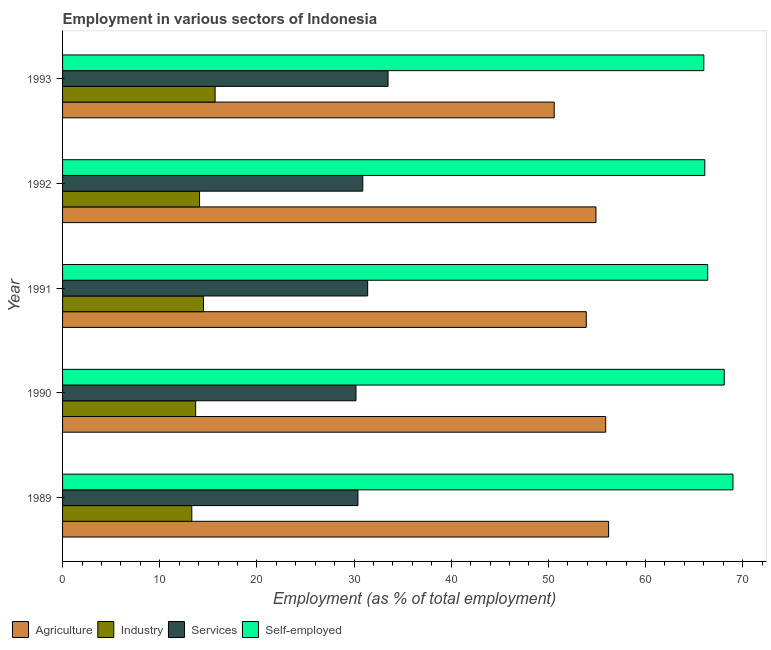How many different coloured bars are there?
Ensure brevity in your answer.  4. How many groups of bars are there?
Your response must be concise. 5. Are the number of bars per tick equal to the number of legend labels?
Your answer should be very brief. Yes. Are the number of bars on each tick of the Y-axis equal?
Keep it short and to the point. Yes. How many bars are there on the 3rd tick from the top?
Offer a terse response. 4. What is the label of the 1st group of bars from the top?
Make the answer very short. 1993. What is the percentage of self employed workers in 1991?
Keep it short and to the point. 66.4. Across all years, what is the maximum percentage of workers in services?
Offer a terse response. 33.5. Across all years, what is the minimum percentage of self employed workers?
Your answer should be very brief. 66. In which year was the percentage of workers in services maximum?
Provide a short and direct response. 1993. What is the total percentage of workers in industry in the graph?
Offer a terse response. 71.3. What is the average percentage of workers in services per year?
Provide a short and direct response. 31.28. In the year 1993, what is the difference between the percentage of workers in services and percentage of self employed workers?
Offer a very short reply. -32.5. What is the ratio of the percentage of workers in agriculture in 1989 to that in 1991?
Your answer should be very brief. 1.04. What does the 2nd bar from the top in 1991 represents?
Your response must be concise. Services. What does the 4th bar from the bottom in 1992 represents?
Keep it short and to the point. Self-employed. Is it the case that in every year, the sum of the percentage of workers in agriculture and percentage of workers in industry is greater than the percentage of workers in services?
Your answer should be compact. Yes. How many bars are there?
Provide a succinct answer. 20. Are all the bars in the graph horizontal?
Provide a succinct answer. Yes. How many years are there in the graph?
Offer a terse response. 5. Does the graph contain grids?
Offer a terse response. No. How many legend labels are there?
Give a very brief answer. 4. What is the title of the graph?
Give a very brief answer. Employment in various sectors of Indonesia. Does "Secondary schools" appear as one of the legend labels in the graph?
Ensure brevity in your answer.  No. What is the label or title of the X-axis?
Your answer should be very brief. Employment (as % of total employment). What is the Employment (as % of total employment) of Agriculture in 1989?
Provide a succinct answer. 56.2. What is the Employment (as % of total employment) of Industry in 1989?
Ensure brevity in your answer.  13.3. What is the Employment (as % of total employment) of Services in 1989?
Your answer should be very brief. 30.4. What is the Employment (as % of total employment) of Self-employed in 1989?
Provide a succinct answer. 69. What is the Employment (as % of total employment) in Agriculture in 1990?
Provide a short and direct response. 55.9. What is the Employment (as % of total employment) in Industry in 1990?
Make the answer very short. 13.7. What is the Employment (as % of total employment) of Services in 1990?
Your answer should be very brief. 30.2. What is the Employment (as % of total employment) of Self-employed in 1990?
Your answer should be compact. 68.1. What is the Employment (as % of total employment) of Agriculture in 1991?
Provide a short and direct response. 53.9. What is the Employment (as % of total employment) of Services in 1991?
Your answer should be compact. 31.4. What is the Employment (as % of total employment) in Self-employed in 1991?
Your response must be concise. 66.4. What is the Employment (as % of total employment) of Agriculture in 1992?
Offer a very short reply. 54.9. What is the Employment (as % of total employment) in Industry in 1992?
Your answer should be very brief. 14.1. What is the Employment (as % of total employment) in Services in 1992?
Your answer should be compact. 30.9. What is the Employment (as % of total employment) in Self-employed in 1992?
Provide a short and direct response. 66.1. What is the Employment (as % of total employment) in Agriculture in 1993?
Your response must be concise. 50.6. What is the Employment (as % of total employment) in Industry in 1993?
Make the answer very short. 15.7. What is the Employment (as % of total employment) of Services in 1993?
Give a very brief answer. 33.5. Across all years, what is the maximum Employment (as % of total employment) of Agriculture?
Make the answer very short. 56.2. Across all years, what is the maximum Employment (as % of total employment) of Industry?
Your answer should be compact. 15.7. Across all years, what is the maximum Employment (as % of total employment) in Services?
Keep it short and to the point. 33.5. Across all years, what is the minimum Employment (as % of total employment) of Agriculture?
Your answer should be compact. 50.6. Across all years, what is the minimum Employment (as % of total employment) in Industry?
Ensure brevity in your answer.  13.3. Across all years, what is the minimum Employment (as % of total employment) of Services?
Offer a very short reply. 30.2. Across all years, what is the minimum Employment (as % of total employment) of Self-employed?
Provide a short and direct response. 66. What is the total Employment (as % of total employment) of Agriculture in the graph?
Provide a succinct answer. 271.5. What is the total Employment (as % of total employment) in Industry in the graph?
Give a very brief answer. 71.3. What is the total Employment (as % of total employment) in Services in the graph?
Offer a terse response. 156.4. What is the total Employment (as % of total employment) in Self-employed in the graph?
Keep it short and to the point. 335.6. What is the difference between the Employment (as % of total employment) in Agriculture in 1989 and that in 1990?
Provide a short and direct response. 0.3. What is the difference between the Employment (as % of total employment) of Agriculture in 1989 and that in 1992?
Make the answer very short. 1.3. What is the difference between the Employment (as % of total employment) in Industry in 1989 and that in 1992?
Your answer should be compact. -0.8. What is the difference between the Employment (as % of total employment) of Industry in 1989 and that in 1993?
Give a very brief answer. -2.4. What is the difference between the Employment (as % of total employment) in Agriculture in 1990 and that in 1991?
Your response must be concise. 2. What is the difference between the Employment (as % of total employment) in Industry in 1990 and that in 1991?
Give a very brief answer. -0.8. What is the difference between the Employment (as % of total employment) in Agriculture in 1990 and that in 1992?
Your answer should be compact. 1. What is the difference between the Employment (as % of total employment) in Industry in 1990 and that in 1992?
Ensure brevity in your answer.  -0.4. What is the difference between the Employment (as % of total employment) in Agriculture in 1990 and that in 1993?
Make the answer very short. 5.3. What is the difference between the Employment (as % of total employment) of Services in 1991 and that in 1992?
Make the answer very short. 0.5. What is the difference between the Employment (as % of total employment) of Self-employed in 1991 and that in 1993?
Ensure brevity in your answer.  0.4. What is the difference between the Employment (as % of total employment) of Agriculture in 1992 and that in 1993?
Offer a terse response. 4.3. What is the difference between the Employment (as % of total employment) in Industry in 1992 and that in 1993?
Your answer should be very brief. -1.6. What is the difference between the Employment (as % of total employment) of Self-employed in 1992 and that in 1993?
Keep it short and to the point. 0.1. What is the difference between the Employment (as % of total employment) in Agriculture in 1989 and the Employment (as % of total employment) in Industry in 1990?
Keep it short and to the point. 42.5. What is the difference between the Employment (as % of total employment) in Agriculture in 1989 and the Employment (as % of total employment) in Services in 1990?
Offer a very short reply. 26. What is the difference between the Employment (as % of total employment) of Agriculture in 1989 and the Employment (as % of total employment) of Self-employed in 1990?
Make the answer very short. -11.9. What is the difference between the Employment (as % of total employment) of Industry in 1989 and the Employment (as % of total employment) of Services in 1990?
Offer a very short reply. -16.9. What is the difference between the Employment (as % of total employment) of Industry in 1989 and the Employment (as % of total employment) of Self-employed in 1990?
Your response must be concise. -54.8. What is the difference between the Employment (as % of total employment) in Services in 1989 and the Employment (as % of total employment) in Self-employed in 1990?
Offer a very short reply. -37.7. What is the difference between the Employment (as % of total employment) of Agriculture in 1989 and the Employment (as % of total employment) of Industry in 1991?
Provide a short and direct response. 41.7. What is the difference between the Employment (as % of total employment) of Agriculture in 1989 and the Employment (as % of total employment) of Services in 1991?
Make the answer very short. 24.8. What is the difference between the Employment (as % of total employment) in Industry in 1989 and the Employment (as % of total employment) in Services in 1991?
Your answer should be compact. -18.1. What is the difference between the Employment (as % of total employment) of Industry in 1989 and the Employment (as % of total employment) of Self-employed in 1991?
Your response must be concise. -53.1. What is the difference between the Employment (as % of total employment) in Services in 1989 and the Employment (as % of total employment) in Self-employed in 1991?
Make the answer very short. -36. What is the difference between the Employment (as % of total employment) of Agriculture in 1989 and the Employment (as % of total employment) of Industry in 1992?
Ensure brevity in your answer.  42.1. What is the difference between the Employment (as % of total employment) of Agriculture in 1989 and the Employment (as % of total employment) of Services in 1992?
Provide a succinct answer. 25.3. What is the difference between the Employment (as % of total employment) of Agriculture in 1989 and the Employment (as % of total employment) of Self-employed in 1992?
Provide a short and direct response. -9.9. What is the difference between the Employment (as % of total employment) of Industry in 1989 and the Employment (as % of total employment) of Services in 1992?
Your answer should be compact. -17.6. What is the difference between the Employment (as % of total employment) of Industry in 1989 and the Employment (as % of total employment) of Self-employed in 1992?
Ensure brevity in your answer.  -52.8. What is the difference between the Employment (as % of total employment) in Services in 1989 and the Employment (as % of total employment) in Self-employed in 1992?
Ensure brevity in your answer.  -35.7. What is the difference between the Employment (as % of total employment) of Agriculture in 1989 and the Employment (as % of total employment) of Industry in 1993?
Keep it short and to the point. 40.5. What is the difference between the Employment (as % of total employment) in Agriculture in 1989 and the Employment (as % of total employment) in Services in 1993?
Make the answer very short. 22.7. What is the difference between the Employment (as % of total employment) of Industry in 1989 and the Employment (as % of total employment) of Services in 1993?
Keep it short and to the point. -20.2. What is the difference between the Employment (as % of total employment) in Industry in 1989 and the Employment (as % of total employment) in Self-employed in 1993?
Offer a terse response. -52.7. What is the difference between the Employment (as % of total employment) of Services in 1989 and the Employment (as % of total employment) of Self-employed in 1993?
Make the answer very short. -35.6. What is the difference between the Employment (as % of total employment) of Agriculture in 1990 and the Employment (as % of total employment) of Industry in 1991?
Provide a short and direct response. 41.4. What is the difference between the Employment (as % of total employment) of Agriculture in 1990 and the Employment (as % of total employment) of Services in 1991?
Your response must be concise. 24.5. What is the difference between the Employment (as % of total employment) in Industry in 1990 and the Employment (as % of total employment) in Services in 1991?
Provide a succinct answer. -17.7. What is the difference between the Employment (as % of total employment) of Industry in 1990 and the Employment (as % of total employment) of Self-employed in 1991?
Keep it short and to the point. -52.7. What is the difference between the Employment (as % of total employment) of Services in 1990 and the Employment (as % of total employment) of Self-employed in 1991?
Ensure brevity in your answer.  -36.2. What is the difference between the Employment (as % of total employment) in Agriculture in 1990 and the Employment (as % of total employment) in Industry in 1992?
Offer a very short reply. 41.8. What is the difference between the Employment (as % of total employment) of Agriculture in 1990 and the Employment (as % of total employment) of Self-employed in 1992?
Offer a terse response. -10.2. What is the difference between the Employment (as % of total employment) of Industry in 1990 and the Employment (as % of total employment) of Services in 1992?
Give a very brief answer. -17.2. What is the difference between the Employment (as % of total employment) of Industry in 1990 and the Employment (as % of total employment) of Self-employed in 1992?
Provide a succinct answer. -52.4. What is the difference between the Employment (as % of total employment) in Services in 1990 and the Employment (as % of total employment) in Self-employed in 1992?
Provide a succinct answer. -35.9. What is the difference between the Employment (as % of total employment) of Agriculture in 1990 and the Employment (as % of total employment) of Industry in 1993?
Make the answer very short. 40.2. What is the difference between the Employment (as % of total employment) of Agriculture in 1990 and the Employment (as % of total employment) of Services in 1993?
Give a very brief answer. 22.4. What is the difference between the Employment (as % of total employment) of Agriculture in 1990 and the Employment (as % of total employment) of Self-employed in 1993?
Offer a very short reply. -10.1. What is the difference between the Employment (as % of total employment) in Industry in 1990 and the Employment (as % of total employment) in Services in 1993?
Offer a very short reply. -19.8. What is the difference between the Employment (as % of total employment) in Industry in 1990 and the Employment (as % of total employment) in Self-employed in 1993?
Offer a terse response. -52.3. What is the difference between the Employment (as % of total employment) of Services in 1990 and the Employment (as % of total employment) of Self-employed in 1993?
Ensure brevity in your answer.  -35.8. What is the difference between the Employment (as % of total employment) of Agriculture in 1991 and the Employment (as % of total employment) of Industry in 1992?
Keep it short and to the point. 39.8. What is the difference between the Employment (as % of total employment) of Agriculture in 1991 and the Employment (as % of total employment) of Services in 1992?
Your response must be concise. 23. What is the difference between the Employment (as % of total employment) of Industry in 1991 and the Employment (as % of total employment) of Services in 1992?
Provide a short and direct response. -16.4. What is the difference between the Employment (as % of total employment) in Industry in 1991 and the Employment (as % of total employment) in Self-employed in 1992?
Ensure brevity in your answer.  -51.6. What is the difference between the Employment (as % of total employment) of Services in 1991 and the Employment (as % of total employment) of Self-employed in 1992?
Give a very brief answer. -34.7. What is the difference between the Employment (as % of total employment) in Agriculture in 1991 and the Employment (as % of total employment) in Industry in 1993?
Keep it short and to the point. 38.2. What is the difference between the Employment (as % of total employment) of Agriculture in 1991 and the Employment (as % of total employment) of Services in 1993?
Ensure brevity in your answer.  20.4. What is the difference between the Employment (as % of total employment) of Industry in 1991 and the Employment (as % of total employment) of Services in 1993?
Provide a succinct answer. -19. What is the difference between the Employment (as % of total employment) of Industry in 1991 and the Employment (as % of total employment) of Self-employed in 1993?
Your response must be concise. -51.5. What is the difference between the Employment (as % of total employment) of Services in 1991 and the Employment (as % of total employment) of Self-employed in 1993?
Offer a very short reply. -34.6. What is the difference between the Employment (as % of total employment) in Agriculture in 1992 and the Employment (as % of total employment) in Industry in 1993?
Give a very brief answer. 39.2. What is the difference between the Employment (as % of total employment) of Agriculture in 1992 and the Employment (as % of total employment) of Services in 1993?
Make the answer very short. 21.4. What is the difference between the Employment (as % of total employment) of Agriculture in 1992 and the Employment (as % of total employment) of Self-employed in 1993?
Your answer should be very brief. -11.1. What is the difference between the Employment (as % of total employment) in Industry in 1992 and the Employment (as % of total employment) in Services in 1993?
Make the answer very short. -19.4. What is the difference between the Employment (as % of total employment) in Industry in 1992 and the Employment (as % of total employment) in Self-employed in 1993?
Your answer should be compact. -51.9. What is the difference between the Employment (as % of total employment) in Services in 1992 and the Employment (as % of total employment) in Self-employed in 1993?
Your response must be concise. -35.1. What is the average Employment (as % of total employment) of Agriculture per year?
Your answer should be very brief. 54.3. What is the average Employment (as % of total employment) of Industry per year?
Offer a very short reply. 14.26. What is the average Employment (as % of total employment) of Services per year?
Make the answer very short. 31.28. What is the average Employment (as % of total employment) in Self-employed per year?
Provide a short and direct response. 67.12. In the year 1989, what is the difference between the Employment (as % of total employment) in Agriculture and Employment (as % of total employment) in Industry?
Your response must be concise. 42.9. In the year 1989, what is the difference between the Employment (as % of total employment) of Agriculture and Employment (as % of total employment) of Services?
Offer a terse response. 25.8. In the year 1989, what is the difference between the Employment (as % of total employment) in Agriculture and Employment (as % of total employment) in Self-employed?
Make the answer very short. -12.8. In the year 1989, what is the difference between the Employment (as % of total employment) in Industry and Employment (as % of total employment) in Services?
Offer a very short reply. -17.1. In the year 1989, what is the difference between the Employment (as % of total employment) in Industry and Employment (as % of total employment) in Self-employed?
Offer a very short reply. -55.7. In the year 1989, what is the difference between the Employment (as % of total employment) in Services and Employment (as % of total employment) in Self-employed?
Your answer should be very brief. -38.6. In the year 1990, what is the difference between the Employment (as % of total employment) of Agriculture and Employment (as % of total employment) of Industry?
Provide a short and direct response. 42.2. In the year 1990, what is the difference between the Employment (as % of total employment) in Agriculture and Employment (as % of total employment) in Services?
Keep it short and to the point. 25.7. In the year 1990, what is the difference between the Employment (as % of total employment) of Agriculture and Employment (as % of total employment) of Self-employed?
Provide a succinct answer. -12.2. In the year 1990, what is the difference between the Employment (as % of total employment) of Industry and Employment (as % of total employment) of Services?
Your answer should be compact. -16.5. In the year 1990, what is the difference between the Employment (as % of total employment) of Industry and Employment (as % of total employment) of Self-employed?
Offer a terse response. -54.4. In the year 1990, what is the difference between the Employment (as % of total employment) of Services and Employment (as % of total employment) of Self-employed?
Offer a very short reply. -37.9. In the year 1991, what is the difference between the Employment (as % of total employment) of Agriculture and Employment (as % of total employment) of Industry?
Make the answer very short. 39.4. In the year 1991, what is the difference between the Employment (as % of total employment) of Agriculture and Employment (as % of total employment) of Self-employed?
Your answer should be compact. -12.5. In the year 1991, what is the difference between the Employment (as % of total employment) of Industry and Employment (as % of total employment) of Services?
Give a very brief answer. -16.9. In the year 1991, what is the difference between the Employment (as % of total employment) in Industry and Employment (as % of total employment) in Self-employed?
Provide a succinct answer. -51.9. In the year 1991, what is the difference between the Employment (as % of total employment) of Services and Employment (as % of total employment) of Self-employed?
Give a very brief answer. -35. In the year 1992, what is the difference between the Employment (as % of total employment) of Agriculture and Employment (as % of total employment) of Industry?
Your response must be concise. 40.8. In the year 1992, what is the difference between the Employment (as % of total employment) in Industry and Employment (as % of total employment) in Services?
Give a very brief answer. -16.8. In the year 1992, what is the difference between the Employment (as % of total employment) in Industry and Employment (as % of total employment) in Self-employed?
Offer a terse response. -52. In the year 1992, what is the difference between the Employment (as % of total employment) of Services and Employment (as % of total employment) of Self-employed?
Your response must be concise. -35.2. In the year 1993, what is the difference between the Employment (as % of total employment) in Agriculture and Employment (as % of total employment) in Industry?
Offer a very short reply. 34.9. In the year 1993, what is the difference between the Employment (as % of total employment) of Agriculture and Employment (as % of total employment) of Services?
Offer a terse response. 17.1. In the year 1993, what is the difference between the Employment (as % of total employment) of Agriculture and Employment (as % of total employment) of Self-employed?
Offer a very short reply. -15.4. In the year 1993, what is the difference between the Employment (as % of total employment) in Industry and Employment (as % of total employment) in Services?
Your answer should be compact. -17.8. In the year 1993, what is the difference between the Employment (as % of total employment) of Industry and Employment (as % of total employment) of Self-employed?
Keep it short and to the point. -50.3. In the year 1993, what is the difference between the Employment (as % of total employment) of Services and Employment (as % of total employment) of Self-employed?
Your answer should be very brief. -32.5. What is the ratio of the Employment (as % of total employment) of Agriculture in 1989 to that in 1990?
Offer a terse response. 1.01. What is the ratio of the Employment (as % of total employment) in Industry in 1989 to that in 1990?
Ensure brevity in your answer.  0.97. What is the ratio of the Employment (as % of total employment) in Services in 1989 to that in 1990?
Your answer should be compact. 1.01. What is the ratio of the Employment (as % of total employment) of Self-employed in 1989 to that in 1990?
Your answer should be compact. 1.01. What is the ratio of the Employment (as % of total employment) in Agriculture in 1989 to that in 1991?
Ensure brevity in your answer.  1.04. What is the ratio of the Employment (as % of total employment) of Industry in 1989 to that in 1991?
Offer a very short reply. 0.92. What is the ratio of the Employment (as % of total employment) in Services in 1989 to that in 1991?
Your response must be concise. 0.97. What is the ratio of the Employment (as % of total employment) in Self-employed in 1989 to that in 1991?
Give a very brief answer. 1.04. What is the ratio of the Employment (as % of total employment) in Agriculture in 1989 to that in 1992?
Make the answer very short. 1.02. What is the ratio of the Employment (as % of total employment) of Industry in 1989 to that in 1992?
Your response must be concise. 0.94. What is the ratio of the Employment (as % of total employment) of Services in 1989 to that in 1992?
Keep it short and to the point. 0.98. What is the ratio of the Employment (as % of total employment) of Self-employed in 1989 to that in 1992?
Your response must be concise. 1.04. What is the ratio of the Employment (as % of total employment) in Agriculture in 1989 to that in 1993?
Your answer should be very brief. 1.11. What is the ratio of the Employment (as % of total employment) in Industry in 1989 to that in 1993?
Offer a very short reply. 0.85. What is the ratio of the Employment (as % of total employment) in Services in 1989 to that in 1993?
Make the answer very short. 0.91. What is the ratio of the Employment (as % of total employment) of Self-employed in 1989 to that in 1993?
Your answer should be compact. 1.05. What is the ratio of the Employment (as % of total employment) in Agriculture in 1990 to that in 1991?
Offer a very short reply. 1.04. What is the ratio of the Employment (as % of total employment) in Industry in 1990 to that in 1991?
Offer a terse response. 0.94. What is the ratio of the Employment (as % of total employment) of Services in 1990 to that in 1991?
Your response must be concise. 0.96. What is the ratio of the Employment (as % of total employment) of Self-employed in 1990 to that in 1991?
Provide a short and direct response. 1.03. What is the ratio of the Employment (as % of total employment) of Agriculture in 1990 to that in 1992?
Your answer should be very brief. 1.02. What is the ratio of the Employment (as % of total employment) in Industry in 1990 to that in 1992?
Give a very brief answer. 0.97. What is the ratio of the Employment (as % of total employment) of Services in 1990 to that in 1992?
Make the answer very short. 0.98. What is the ratio of the Employment (as % of total employment) of Self-employed in 1990 to that in 1992?
Offer a very short reply. 1.03. What is the ratio of the Employment (as % of total employment) of Agriculture in 1990 to that in 1993?
Keep it short and to the point. 1.1. What is the ratio of the Employment (as % of total employment) in Industry in 1990 to that in 1993?
Ensure brevity in your answer.  0.87. What is the ratio of the Employment (as % of total employment) of Services in 1990 to that in 1993?
Your response must be concise. 0.9. What is the ratio of the Employment (as % of total employment) of Self-employed in 1990 to that in 1993?
Your response must be concise. 1.03. What is the ratio of the Employment (as % of total employment) in Agriculture in 1991 to that in 1992?
Provide a short and direct response. 0.98. What is the ratio of the Employment (as % of total employment) of Industry in 1991 to that in 1992?
Provide a short and direct response. 1.03. What is the ratio of the Employment (as % of total employment) in Services in 1991 to that in 1992?
Your answer should be compact. 1.02. What is the ratio of the Employment (as % of total employment) in Self-employed in 1991 to that in 1992?
Ensure brevity in your answer.  1. What is the ratio of the Employment (as % of total employment) in Agriculture in 1991 to that in 1993?
Your answer should be compact. 1.07. What is the ratio of the Employment (as % of total employment) of Industry in 1991 to that in 1993?
Your answer should be compact. 0.92. What is the ratio of the Employment (as % of total employment) of Services in 1991 to that in 1993?
Provide a succinct answer. 0.94. What is the ratio of the Employment (as % of total employment) of Agriculture in 1992 to that in 1993?
Offer a very short reply. 1.08. What is the ratio of the Employment (as % of total employment) of Industry in 1992 to that in 1993?
Your response must be concise. 0.9. What is the ratio of the Employment (as % of total employment) of Services in 1992 to that in 1993?
Your answer should be compact. 0.92. What is the ratio of the Employment (as % of total employment) of Self-employed in 1992 to that in 1993?
Ensure brevity in your answer.  1. What is the difference between the highest and the second highest Employment (as % of total employment) in Industry?
Your response must be concise. 1.2. What is the difference between the highest and the second highest Employment (as % of total employment) of Services?
Make the answer very short. 2.1. What is the difference between the highest and the second highest Employment (as % of total employment) in Self-employed?
Make the answer very short. 0.9. What is the difference between the highest and the lowest Employment (as % of total employment) of Industry?
Give a very brief answer. 2.4. 